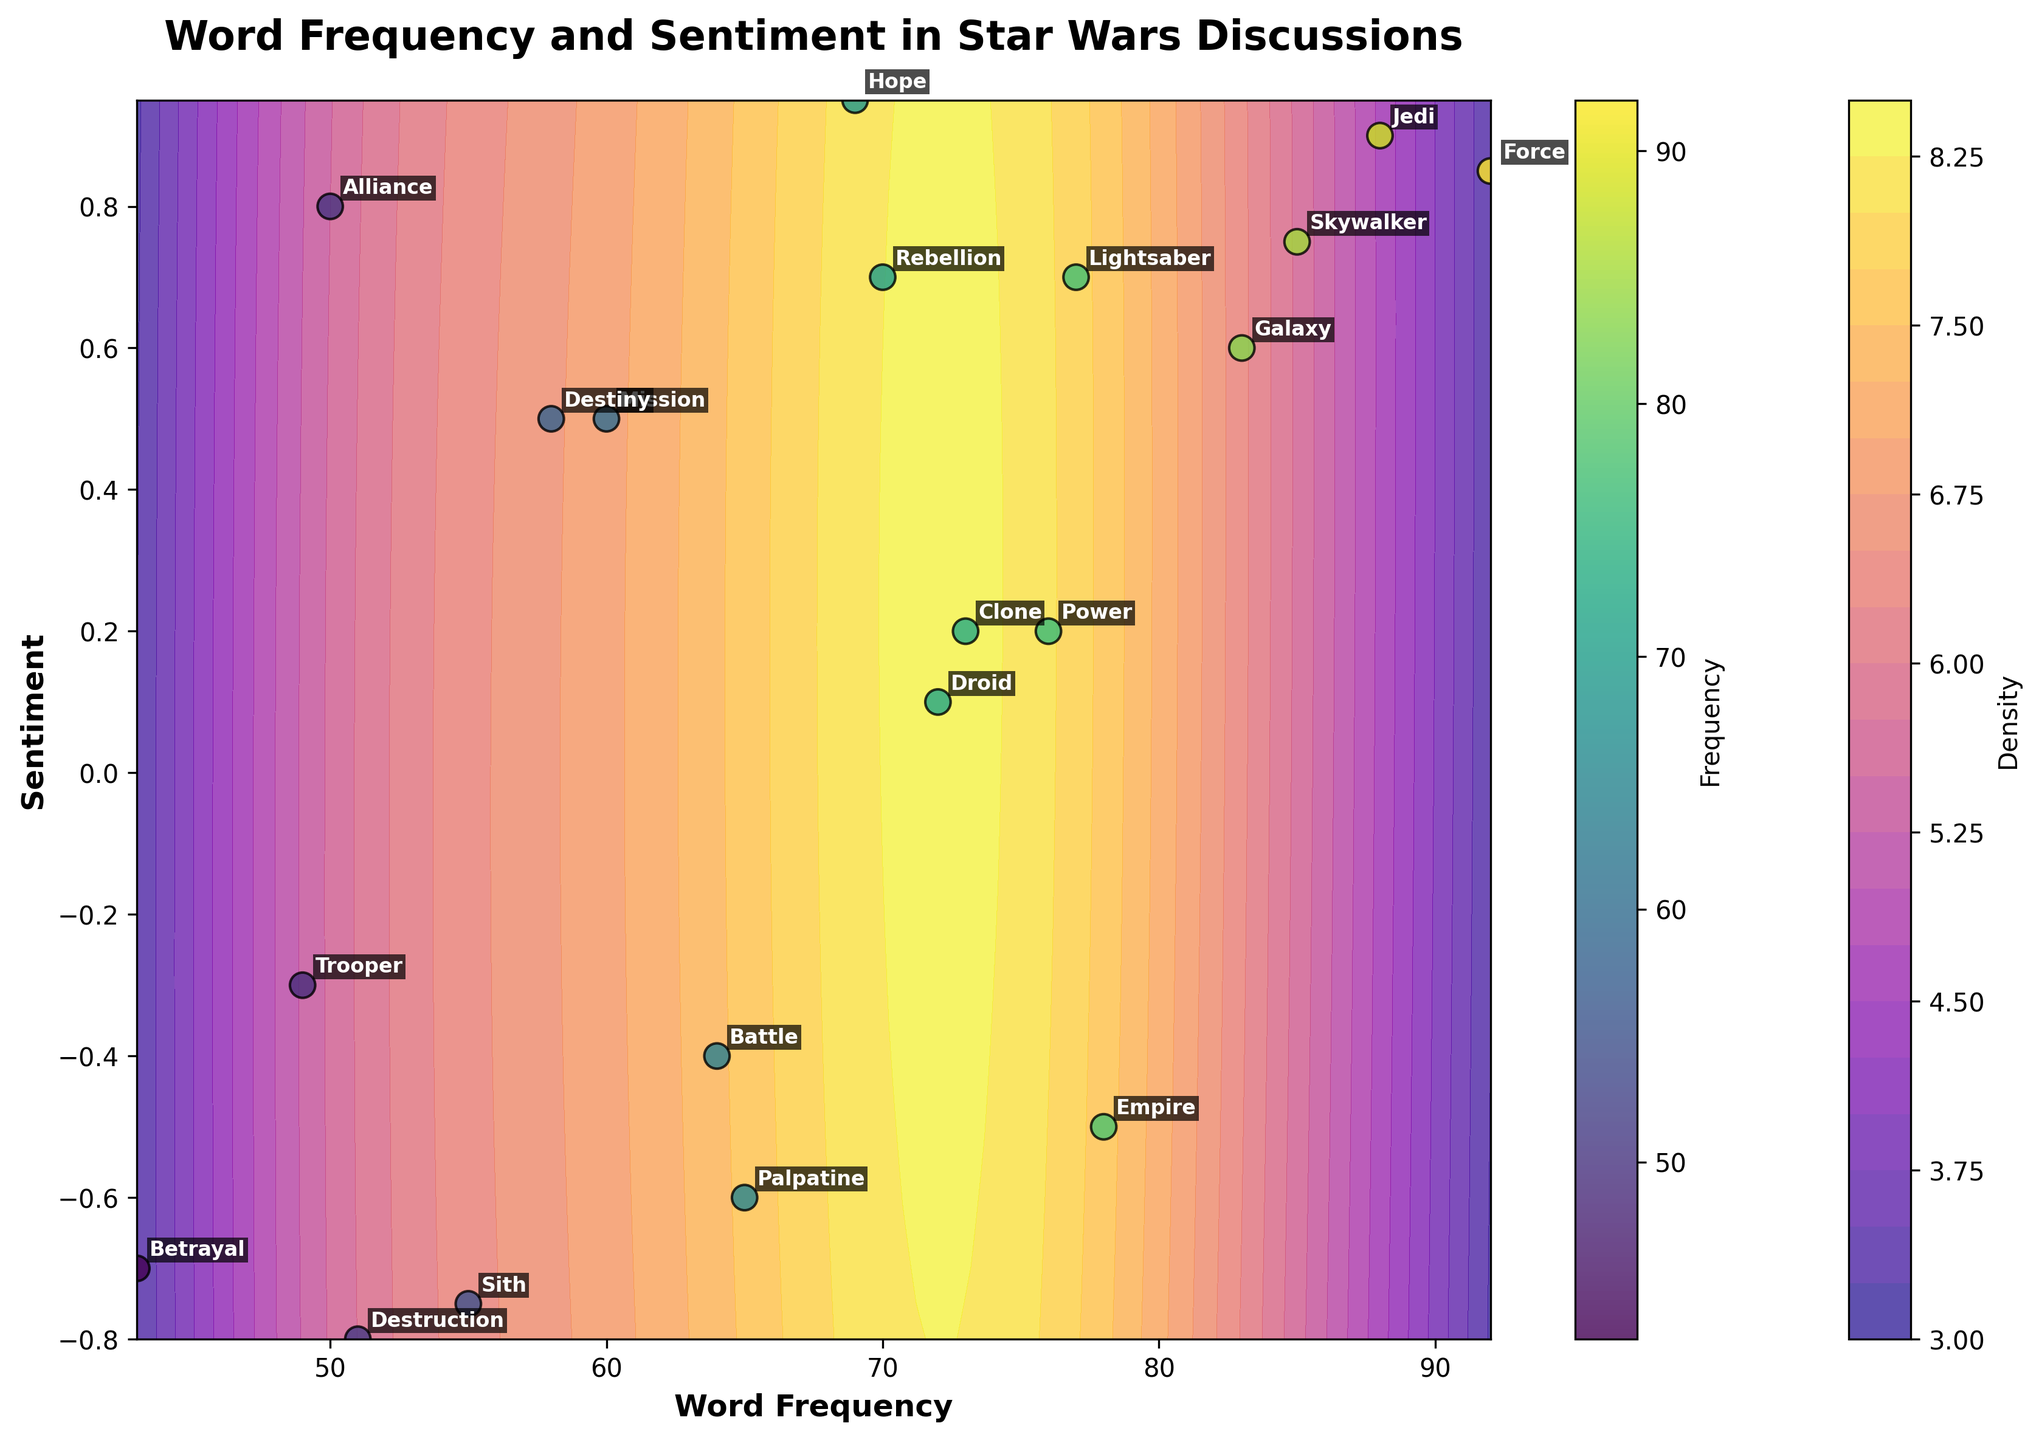What is the title of the figure? The title is the text at the top of the figure, which describes the main topic or focus. The title of the figure is "Word Frequency and Sentiment in Star Wars Discussions".
Answer: Word Frequency and Sentiment in Star Wars Discussions What are the axes labeled? The labels on the horizontal and vertical axes provide information about what is being measured. The horizontal axis is labeled "Word Frequency" and the vertical axis is labeled "Sentiment".
Answer: Word Frequency, Sentiment Which word has the highest frequency? To find the word with the highest frequency, look for the data point farthest to the right on the horizontal axis. "Force" is plotted at the highest frequency of 92.
Answer: Force Which word has the most negative sentiment? To determine the word with the most negative sentiment, find the data point lowest on the vertical axis. "Destruction" is annotated at the lowest sentiment of -0.80.
Answer: Destruction How many words have a sentiment higher than 0.5? Count the number of data points with sentiments above the 0.5 mark on the vertical axis. The words are "Alliance", "Force", "Jedi", "Lightsaber", "Rebellion", "Hope", and "Galaxy", totaling seven.
Answer: 7 Which word has the lowest frequency? To find the word with the lowest frequency, check the data point closest to the left on the horizontal axis. The word "Trooper" has the lowest frequency of 49.
Answer: Trooper Compare the frequency of "Skywalker" and "Empire". Which is higher? To compare the frequencies, find the horizontal positions of "Skywalker" and "Empire" and determine which is farther to the right. "Skywalker" at 85 is higher in frequency than "Empire" at 78.
Answer: Skywalker Which region has the highest density of words based on the contour plot? The highest density region on a contour plot is indicated by the darkest color bands. The area around the points with frequencies close to 70 and sentiments between 0.5 and 0.8 shows the highest density of words.
Answer: Frequencies around 70, sentiments between 0.5 and 0.8 What is the average sentiment of the words "Clone", "Droid", and "Power"? To calculate the average sentiment, add the sentiments of "Clone" (0.20), "Droid" (0.10), and "Power" (0.20) and divide by 3. (0.20 + 0.10 + 0.20) / 3 = 0.17
Answer: 0.17 